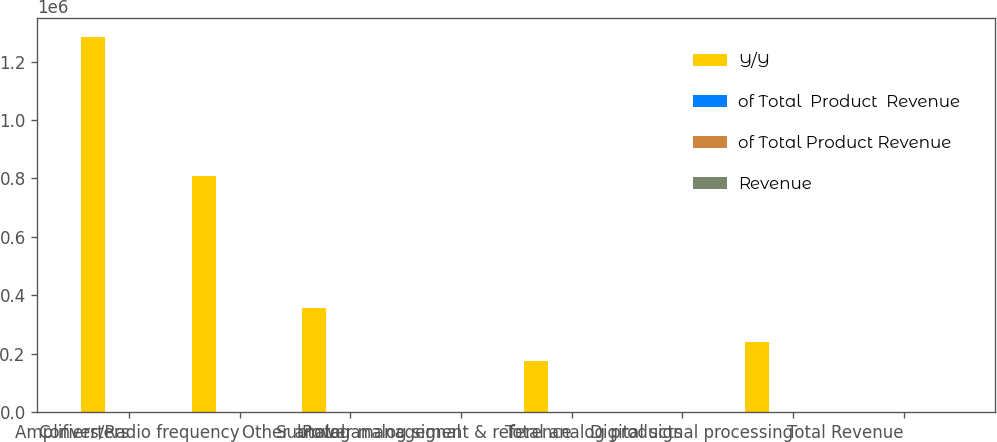<chart> <loc_0><loc_0><loc_500><loc_500><stacked_bar_chart><ecel><fcel>Converters<fcel>Amplifiers/Radio frequency<fcel>Other analog<fcel>Subtotal analog signal<fcel>Power management & reference<fcel>Total analog products<fcel>Digital signal processing<fcel>Total Revenue<nl><fcel>Y/Y<fcel>1.28537e+06<fcel>806975<fcel>356406<fcel>26<fcel>174483<fcel>26<fcel>241541<fcel>26<nl><fcel>of Total  Product  Revenue<fcel>45<fcel>28<fcel>12<fcel>85<fcel>6<fcel>92<fcel>8<fcel>100<nl><fcel>of Total Product Revenue<fcel>9<fcel>18<fcel>4<fcel>10<fcel>1<fcel>9<fcel>7<fcel>9<nl><fcel>Revenue<fcel>44<fcel>26<fcel>15<fcel>85<fcel>7<fcel>91<fcel>9<fcel>100<nl></chart> 